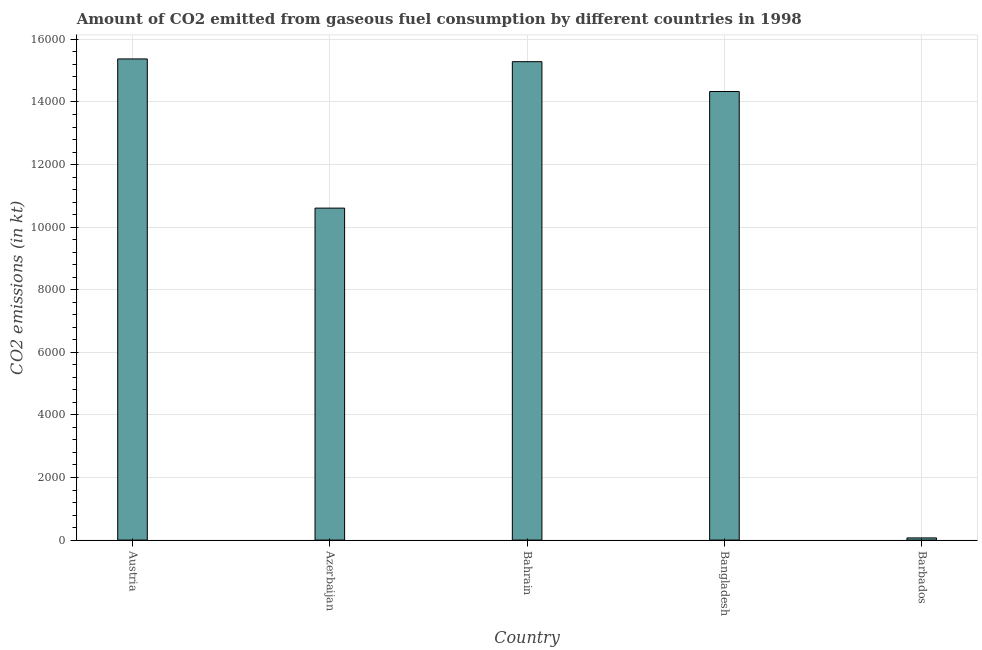What is the title of the graph?
Ensure brevity in your answer.  Amount of CO2 emitted from gaseous fuel consumption by different countries in 1998. What is the label or title of the Y-axis?
Provide a succinct answer. CO2 emissions (in kt). What is the co2 emissions from gaseous fuel consumption in Azerbaijan?
Ensure brevity in your answer.  1.06e+04. Across all countries, what is the maximum co2 emissions from gaseous fuel consumption?
Provide a short and direct response. 1.54e+04. Across all countries, what is the minimum co2 emissions from gaseous fuel consumption?
Ensure brevity in your answer.  69.67. In which country was the co2 emissions from gaseous fuel consumption maximum?
Offer a terse response. Austria. In which country was the co2 emissions from gaseous fuel consumption minimum?
Offer a very short reply. Barbados. What is the sum of the co2 emissions from gaseous fuel consumption?
Your answer should be very brief. 5.57e+04. What is the difference between the co2 emissions from gaseous fuel consumption in Austria and Barbados?
Ensure brevity in your answer.  1.53e+04. What is the average co2 emissions from gaseous fuel consumption per country?
Ensure brevity in your answer.  1.11e+04. What is the median co2 emissions from gaseous fuel consumption?
Make the answer very short. 1.43e+04. In how many countries, is the co2 emissions from gaseous fuel consumption greater than 3200 kt?
Provide a short and direct response. 4. What is the ratio of the co2 emissions from gaseous fuel consumption in Austria to that in Bangladesh?
Your answer should be very brief. 1.07. What is the difference between the highest and the second highest co2 emissions from gaseous fuel consumption?
Your answer should be compact. 88.01. Is the sum of the co2 emissions from gaseous fuel consumption in Austria and Bahrain greater than the maximum co2 emissions from gaseous fuel consumption across all countries?
Provide a succinct answer. Yes. What is the difference between the highest and the lowest co2 emissions from gaseous fuel consumption?
Make the answer very short. 1.53e+04. Are all the bars in the graph horizontal?
Your response must be concise. No. Are the values on the major ticks of Y-axis written in scientific E-notation?
Your response must be concise. No. What is the CO2 emissions (in kt) in Austria?
Offer a terse response. 1.54e+04. What is the CO2 emissions (in kt) of Azerbaijan?
Offer a very short reply. 1.06e+04. What is the CO2 emissions (in kt) of Bahrain?
Your response must be concise. 1.53e+04. What is the CO2 emissions (in kt) of Bangladesh?
Your answer should be very brief. 1.43e+04. What is the CO2 emissions (in kt) of Barbados?
Offer a very short reply. 69.67. What is the difference between the CO2 emissions (in kt) in Austria and Azerbaijan?
Your answer should be compact. 4767.1. What is the difference between the CO2 emissions (in kt) in Austria and Bahrain?
Offer a terse response. 88.01. What is the difference between the CO2 emissions (in kt) in Austria and Bangladesh?
Keep it short and to the point. 1041.43. What is the difference between the CO2 emissions (in kt) in Austria and Barbados?
Offer a terse response. 1.53e+04. What is the difference between the CO2 emissions (in kt) in Azerbaijan and Bahrain?
Ensure brevity in your answer.  -4679.09. What is the difference between the CO2 emissions (in kt) in Azerbaijan and Bangladesh?
Your response must be concise. -3725.67. What is the difference between the CO2 emissions (in kt) in Azerbaijan and Barbados?
Give a very brief answer. 1.05e+04. What is the difference between the CO2 emissions (in kt) in Bahrain and Bangladesh?
Provide a short and direct response. 953.42. What is the difference between the CO2 emissions (in kt) in Bahrain and Barbados?
Ensure brevity in your answer.  1.52e+04. What is the difference between the CO2 emissions (in kt) in Bangladesh and Barbados?
Your response must be concise. 1.43e+04. What is the ratio of the CO2 emissions (in kt) in Austria to that in Azerbaijan?
Offer a very short reply. 1.45. What is the ratio of the CO2 emissions (in kt) in Austria to that in Bangladesh?
Ensure brevity in your answer.  1.07. What is the ratio of the CO2 emissions (in kt) in Austria to that in Barbados?
Keep it short and to the point. 220.68. What is the ratio of the CO2 emissions (in kt) in Azerbaijan to that in Bahrain?
Offer a terse response. 0.69. What is the ratio of the CO2 emissions (in kt) in Azerbaijan to that in Bangladesh?
Your answer should be very brief. 0.74. What is the ratio of the CO2 emissions (in kt) in Azerbaijan to that in Barbados?
Your answer should be compact. 152.26. What is the ratio of the CO2 emissions (in kt) in Bahrain to that in Bangladesh?
Provide a short and direct response. 1.07. What is the ratio of the CO2 emissions (in kt) in Bahrain to that in Barbados?
Offer a very short reply. 219.42. What is the ratio of the CO2 emissions (in kt) in Bangladesh to that in Barbados?
Your answer should be very brief. 205.74. 